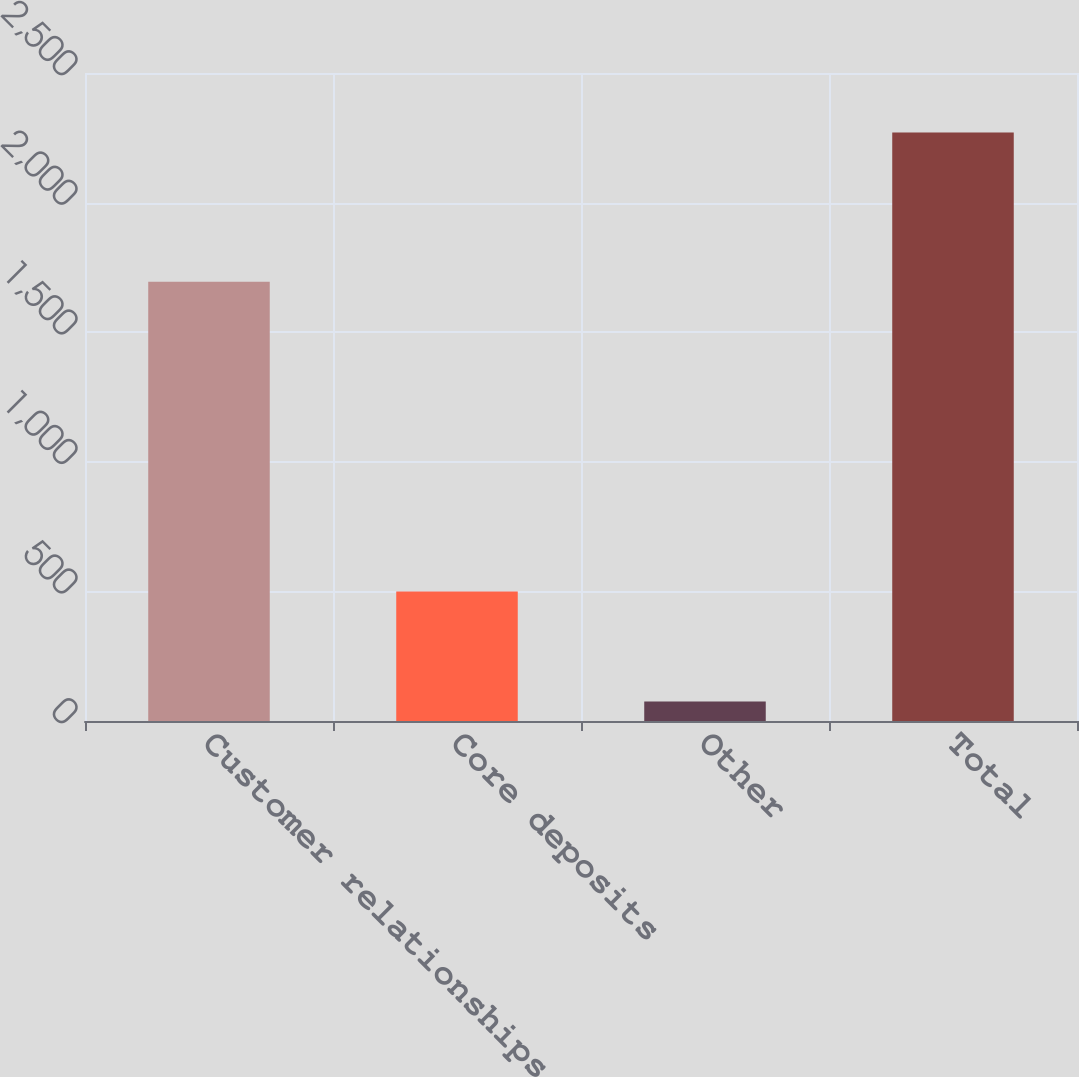Convert chart to OTSL. <chart><loc_0><loc_0><loc_500><loc_500><bar_chart><fcel>Customer relationships<fcel>Core deposits<fcel>Other<fcel>Total<nl><fcel>1695<fcel>500<fcel>75<fcel>2270<nl></chart> 